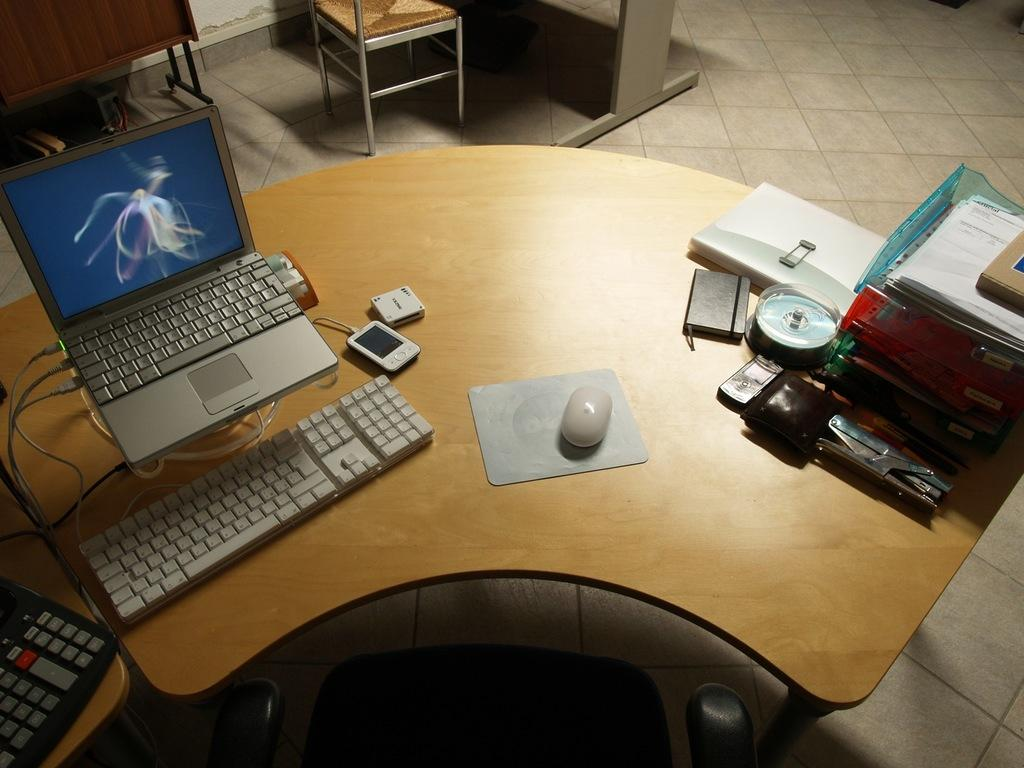What type of furniture is in the image? There is a table in the image. What electronic device is on the table? A laptop is present on the table. What input device is on the table? A keyboard and a mouse are on the table. What communication device is on the table? A mobile phone is on the table. What reading material is on the table? A book is on the table. What work-related item is on the table? A file is on the table. What printing device is on the table? A printer is on the table. What type of seating is in the image? Chairs are present in the image. What type of rake is used to organize the files on the table? There is no rake present in the image, and the files are not being organized with a rake. What order are the items on the table arranged in? The image does not show a specific order for the items on the table. How many rings are visible on the table? There are no rings present on the table in the image. 